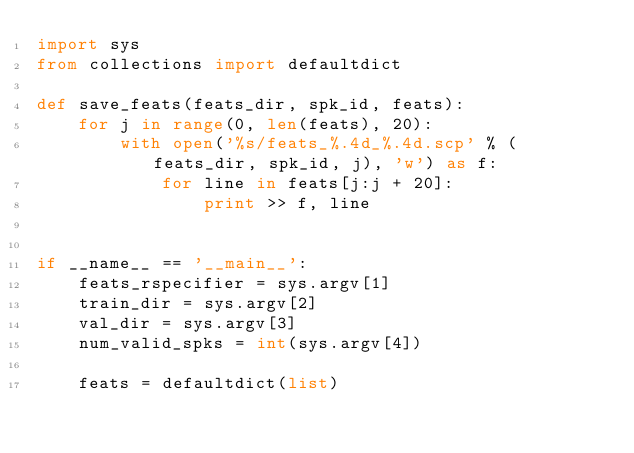<code> <loc_0><loc_0><loc_500><loc_500><_Python_>import sys
from collections import defaultdict

def save_feats(feats_dir, spk_id, feats):
    for j in range(0, len(feats), 20):
        with open('%s/feats_%.4d_%.4d.scp' % (feats_dir, spk_id, j), 'w') as f:
            for line in feats[j:j + 20]:
                print >> f, line


if __name__ == '__main__':
    feats_rspecifier = sys.argv[1]
    train_dir = sys.argv[2]
    val_dir = sys.argv[3]
    num_valid_spks = int(sys.argv[4])

    feats = defaultdict(list)</code> 